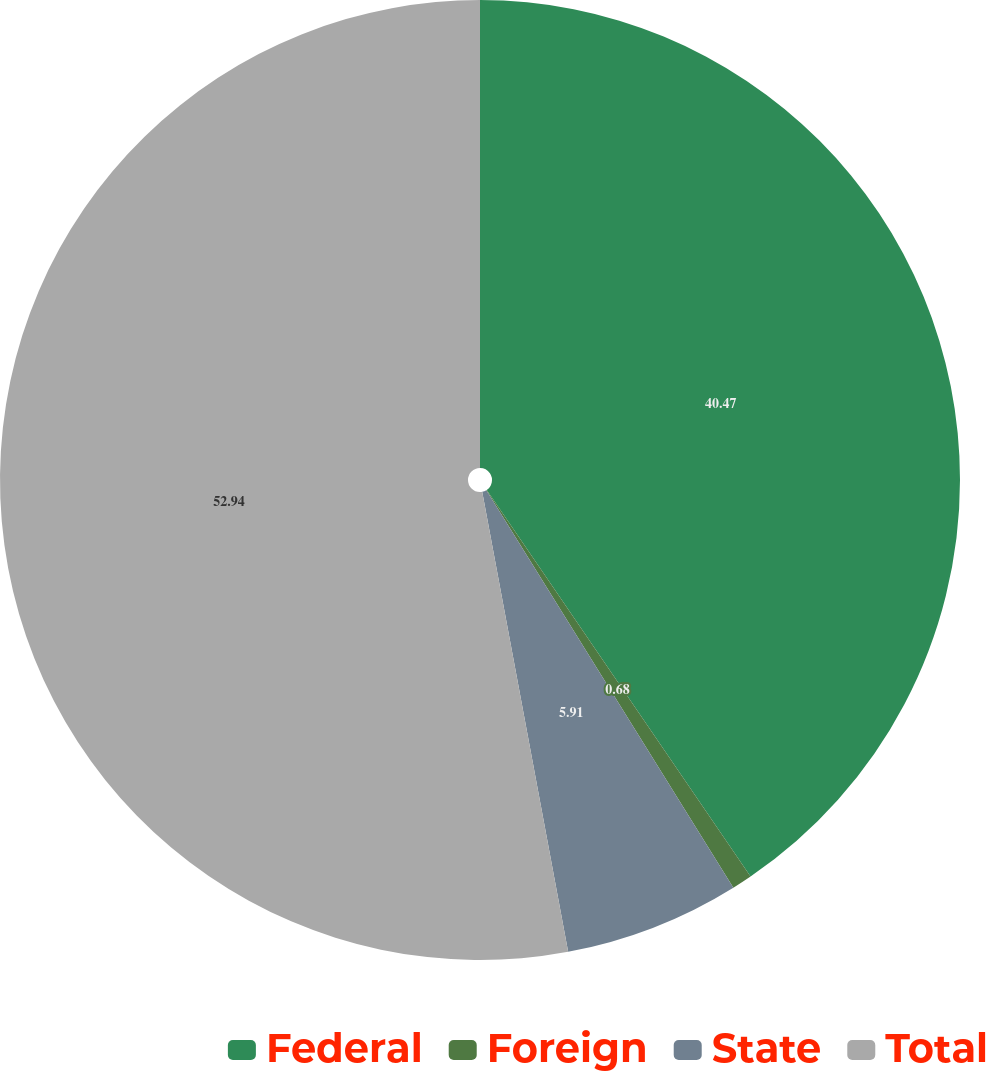<chart> <loc_0><loc_0><loc_500><loc_500><pie_chart><fcel>Federal<fcel>Foreign<fcel>State<fcel>Total<nl><fcel>40.47%<fcel>0.68%<fcel>5.91%<fcel>52.94%<nl></chart> 